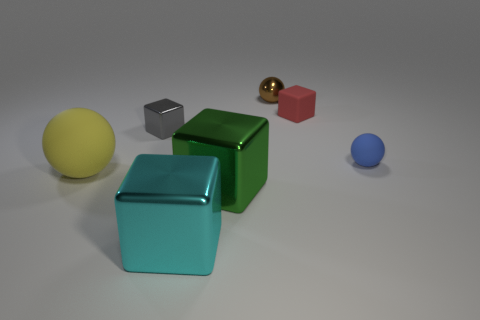Subtract all large yellow spheres. How many spheres are left? 2 Add 2 cyan balls. How many objects exist? 9 Subtract all cyan cubes. How many cubes are left? 3 Subtract 3 cubes. How many cubes are left? 1 Subtract all purple cylinders. How many gray cubes are left? 1 Subtract all metallic spheres. Subtract all gray cubes. How many objects are left? 5 Add 6 large yellow matte balls. How many large yellow matte balls are left? 7 Add 1 tiny brown metal spheres. How many tiny brown metal spheres exist? 2 Subtract 1 yellow spheres. How many objects are left? 6 Subtract all cubes. How many objects are left? 3 